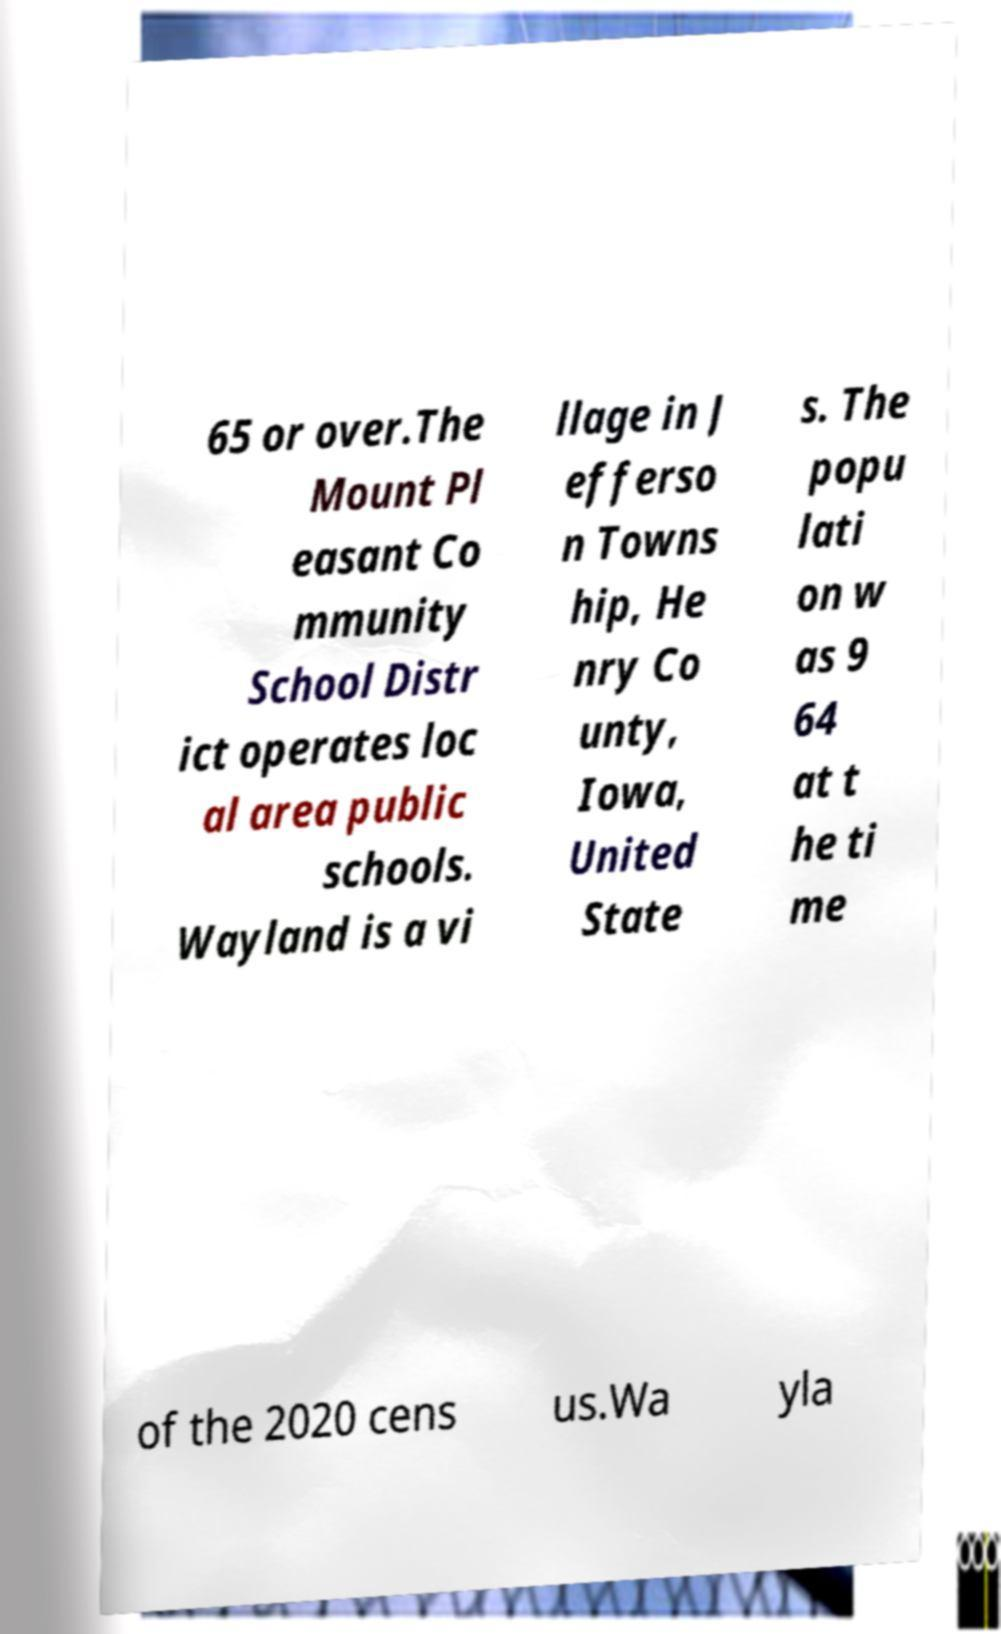Please read and relay the text visible in this image. What does it say? 65 or over.The Mount Pl easant Co mmunity School Distr ict operates loc al area public schools. Wayland is a vi llage in J efferso n Towns hip, He nry Co unty, Iowa, United State s. The popu lati on w as 9 64 at t he ti me of the 2020 cens us.Wa yla 